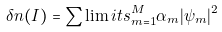<formula> <loc_0><loc_0><loc_500><loc_500>\delta n ( I ) = \sum \lim i t s _ { m = 1 } ^ { M } \alpha _ { m } | \psi _ { m } | ^ { 2 }</formula> 